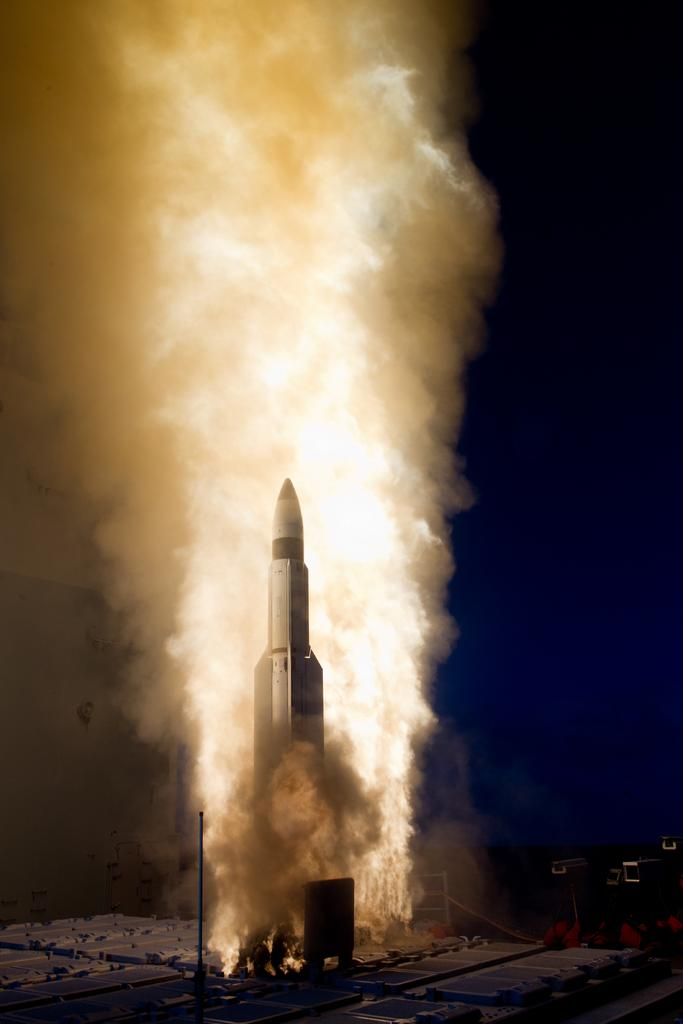What is happening in the image? There is a rocket launch in the image. What can be seen around the rocket? There is fire and smoke around the rocket. How many ducks are swimming in the rocket's fuel tank in the image? There are no ducks present in the image, and the rocket's fuel tank is not visible. 